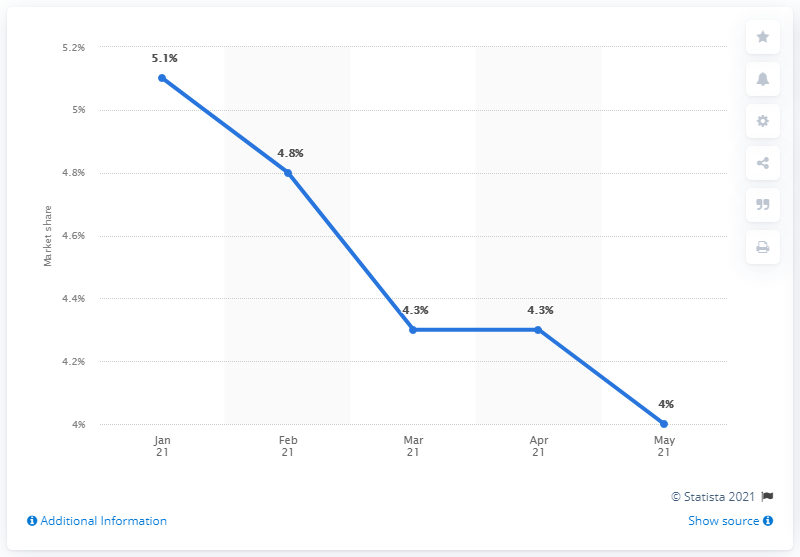Specify some key components in this picture. In May 2021, Ford's EU market share was 4%. 